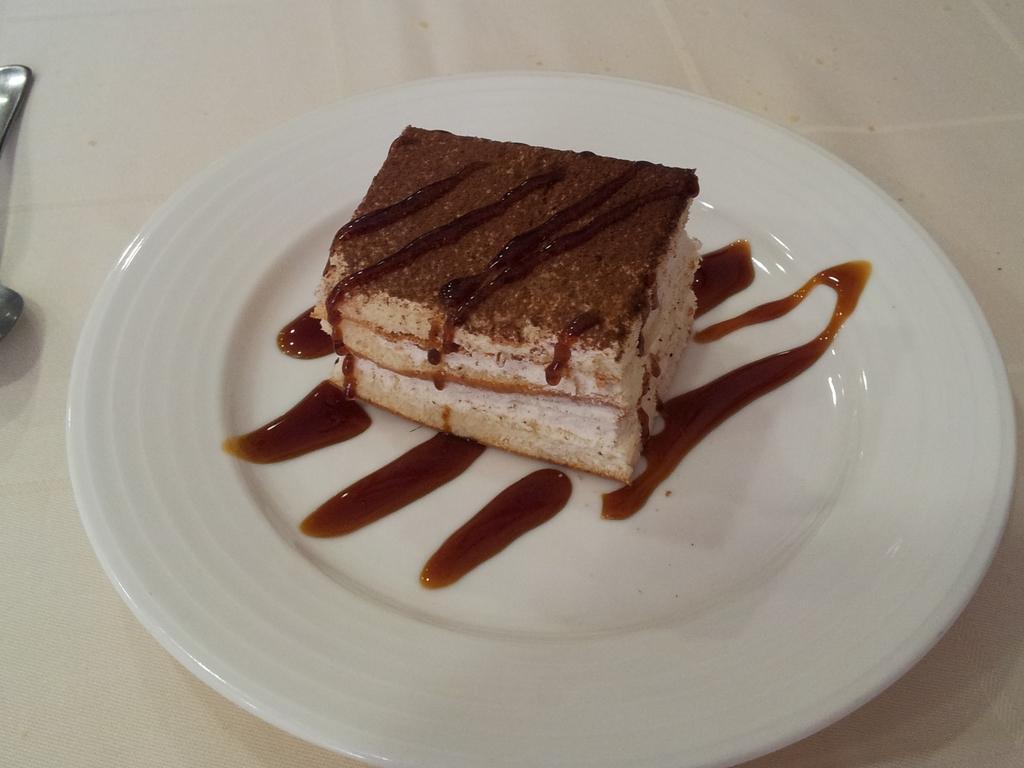Can you describe this image briefly? Here we can see a plate, food, and a spoon on a platform. 